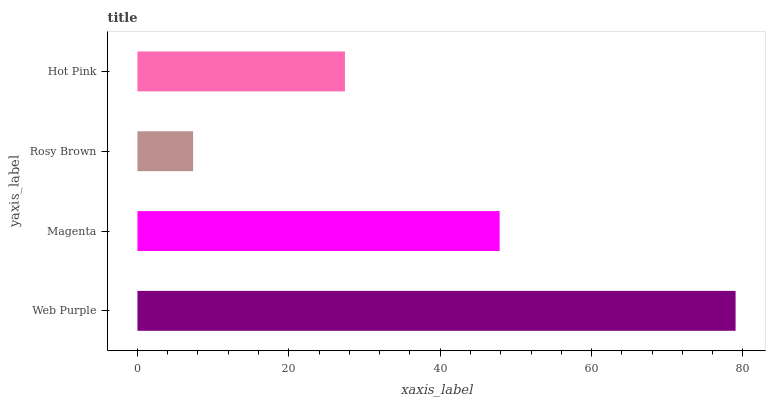Is Rosy Brown the minimum?
Answer yes or no. Yes. Is Web Purple the maximum?
Answer yes or no. Yes. Is Magenta the minimum?
Answer yes or no. No. Is Magenta the maximum?
Answer yes or no. No. Is Web Purple greater than Magenta?
Answer yes or no. Yes. Is Magenta less than Web Purple?
Answer yes or no. Yes. Is Magenta greater than Web Purple?
Answer yes or no. No. Is Web Purple less than Magenta?
Answer yes or no. No. Is Magenta the high median?
Answer yes or no. Yes. Is Hot Pink the low median?
Answer yes or no. Yes. Is Web Purple the high median?
Answer yes or no. No. Is Web Purple the low median?
Answer yes or no. No. 